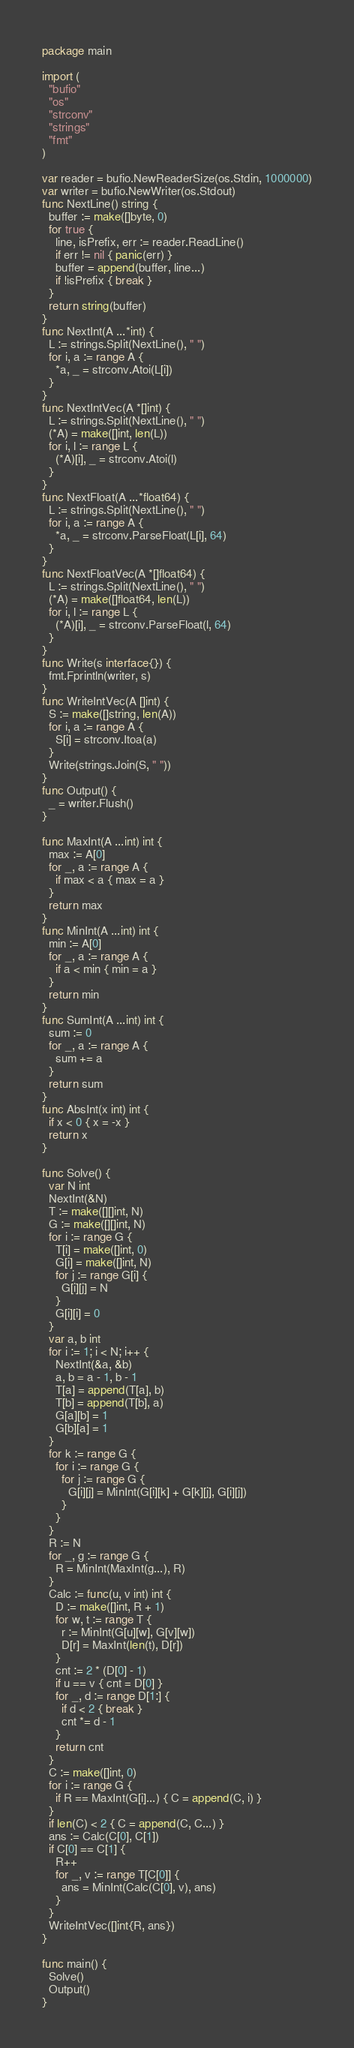<code> <loc_0><loc_0><loc_500><loc_500><_Go_>package main

import (
  "bufio"
  "os"
  "strconv"
  "strings"
  "fmt"
)

var reader = bufio.NewReaderSize(os.Stdin, 1000000)
var writer = bufio.NewWriter(os.Stdout)
func NextLine() string {
  buffer := make([]byte, 0)
  for true {
    line, isPrefix, err := reader.ReadLine()
    if err != nil { panic(err) }
    buffer = append(buffer, line...)
    if !isPrefix { break }
  }
  return string(buffer)
}
func NextInt(A ...*int) {
  L := strings.Split(NextLine(), " ")
  for i, a := range A {
    *a, _ = strconv.Atoi(L[i])
  }
}
func NextIntVec(A *[]int) {
  L := strings.Split(NextLine(), " ")
  (*A) = make([]int, len(L))
  for i, l := range L {
    (*A)[i], _ = strconv.Atoi(l)
  }
}
func NextFloat(A ...*float64) {
  L := strings.Split(NextLine(), " ")
  for i, a := range A {
    *a, _ = strconv.ParseFloat(L[i], 64)
  }
}
func NextFloatVec(A *[]float64) {
  L := strings.Split(NextLine(), " ")
  (*A) = make([]float64, len(L))
  for i, l := range L {
    (*A)[i], _ = strconv.ParseFloat(l, 64)
  }
}
func Write(s interface{}) {
  fmt.Fprintln(writer, s)
}
func WriteIntVec(A []int) {
  S := make([]string, len(A))
  for i, a := range A {
    S[i] = strconv.Itoa(a)
  }
  Write(strings.Join(S, " "))
}
func Output() {
  _ = writer.Flush()
}

func MaxInt(A ...int) int {
  max := A[0]
  for _, a := range A {
    if max < a { max = a }
  }
  return max
}
func MinInt(A ...int) int {
  min := A[0]
  for _, a := range A {
    if a < min { min = a }
  }
  return min
}
func SumInt(A ...int) int {
  sum := 0
  for _, a := range A {
    sum += a
  }
  return sum
}
func AbsInt(x int) int {
  if x < 0 { x = -x }
  return x
}

func Solve() {
  var N int
  NextInt(&N)
  T := make([][]int, N)
  G := make([][]int, N)
  for i := range G {
    T[i] = make([]int, 0)
    G[i] = make([]int, N)
    for j := range G[i] {
      G[i][j] = N
    }
    G[i][i] = 0
  }
  var a, b int
  for i := 1; i < N; i++ {
    NextInt(&a, &b)
    a, b = a - 1, b - 1
    T[a] = append(T[a], b)
    T[b] = append(T[b], a)
    G[a][b] = 1
    G[b][a] = 1
  }
  for k := range G {
    for i := range G {
      for j := range G {
        G[i][j] = MinInt(G[i][k] + G[k][j], G[i][j])
      }
    }
  }
  R := N
  for _, g := range G {
    R = MinInt(MaxInt(g...), R)
  }
  Calc := func(u, v int) int {
    D := make([]int, R + 1)
    for w, t := range T {
      r := MinInt(G[u][w], G[v][w])
      D[r] = MaxInt(len(t), D[r])
    }
    cnt := 2 * (D[0] - 1)
    if u == v { cnt = D[0] }
    for _, d := range D[1:] {
      if d < 2 { break }
      cnt *= d - 1
    }
    return cnt
  }
  C := make([]int, 0)
  for i := range G {
    if R == MaxInt(G[i]...) { C = append(C, i) }
  }
  if len(C) < 2 { C = append(C, C...) }
  ans := Calc(C[0], C[1])
  if C[0] == C[1] {
    R++
    for _, v := range T[C[0]] {
      ans = MinInt(Calc(C[0], v), ans)
    }
  }
  WriteIntVec([]int{R, ans})
}

func main() {
  Solve()
  Output()
}</code> 